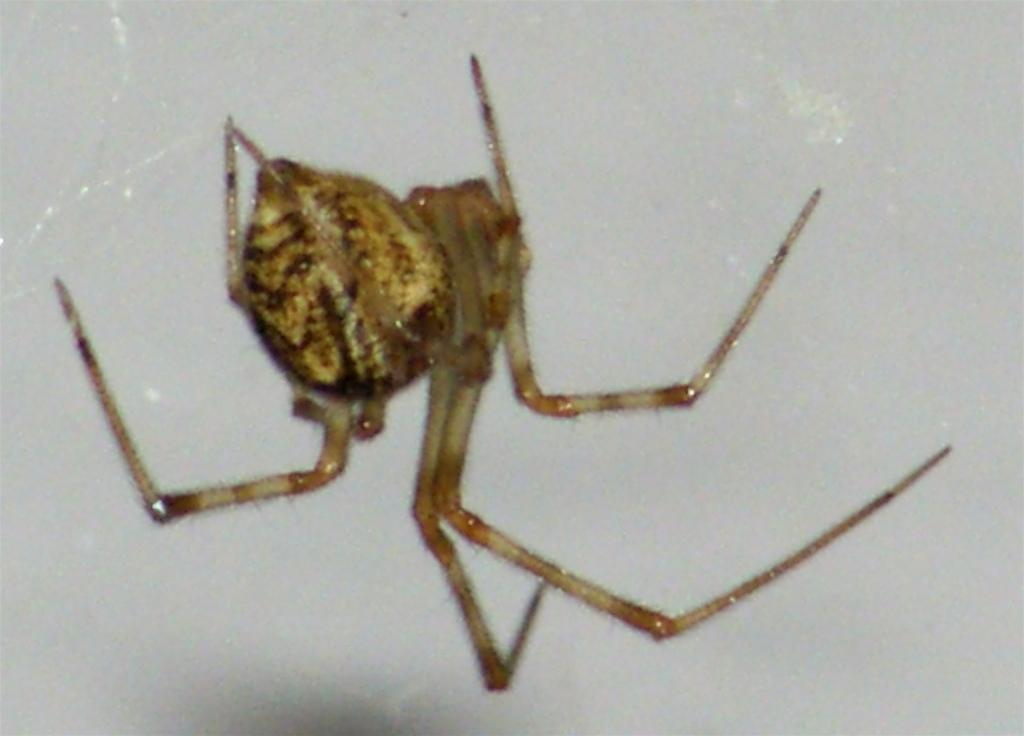What is present in the image? There is a spider in the image. Where is the spider located? The spider is on a wall. What question is the spider asking in the image? There is no indication in the image that the spider is asking a question, as spiders do not have the ability to communicate in this manner. 